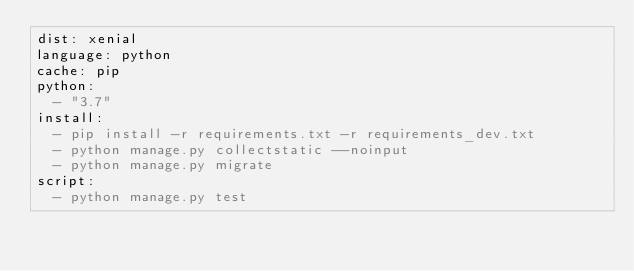<code> <loc_0><loc_0><loc_500><loc_500><_YAML_>dist: xenial
language: python
cache: pip
python:
  - "3.7"
install:
  - pip install -r requirements.txt -r requirements_dev.txt
  - python manage.py collectstatic --noinput
  - python manage.py migrate
script:
  - python manage.py test</code> 